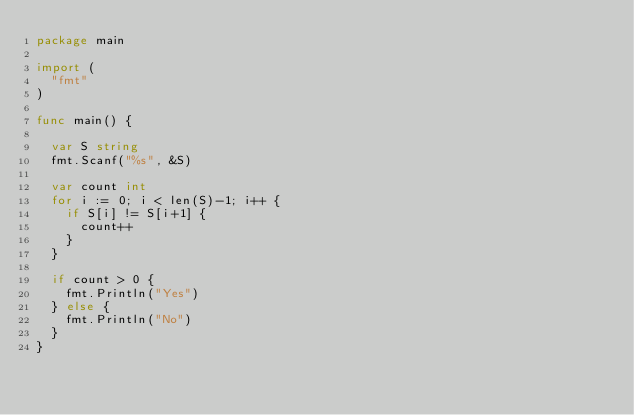<code> <loc_0><loc_0><loc_500><loc_500><_Go_>package main

import (
	"fmt"
)

func main() {

	var S string
	fmt.Scanf("%s", &S)

	var count int
	for i := 0; i < len(S)-1; i++ {
		if S[i] != S[i+1] {
			count++
		}
	}

	if count > 0 {
		fmt.Println("Yes")
	} else {
		fmt.Println("No")
	}
}
</code> 